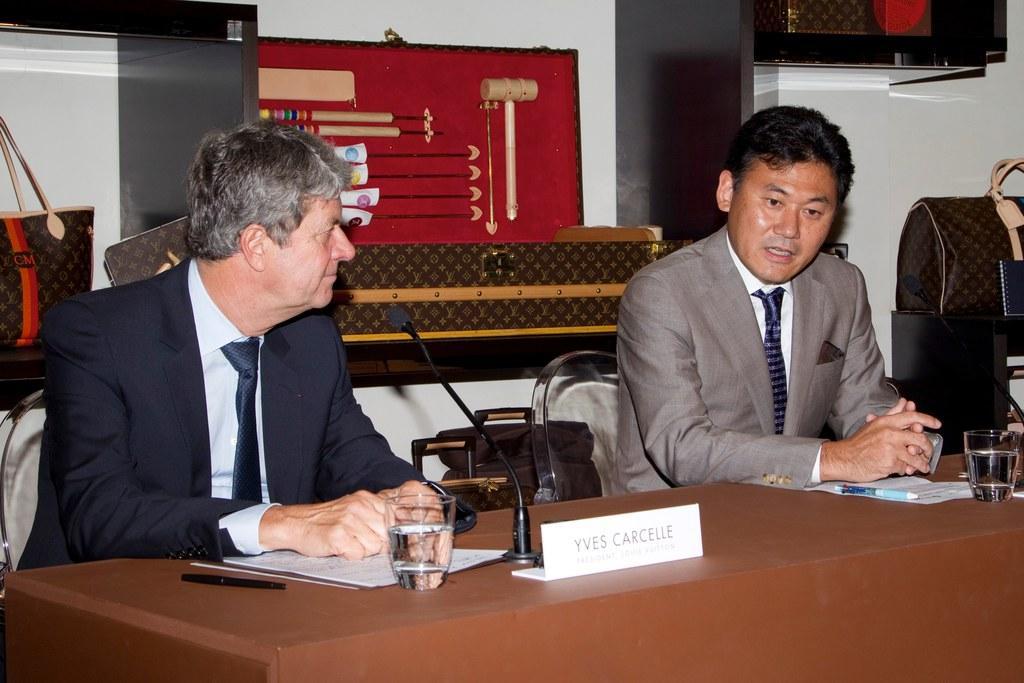Can you describe this image briefly? In this picture, we can see a few people sitting on chairs, and resting their hands on table, we can see table and some objects on the table like papers, pens, glass, microphone, and in the background we can see the wall with shelves, and some objects attached to it, we can see some objects on the right side of the picture. 